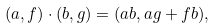Convert formula to latex. <formula><loc_0><loc_0><loc_500><loc_500>( a , f ) \cdot ( b , g ) = ( a b , a g + f b ) ,</formula> 